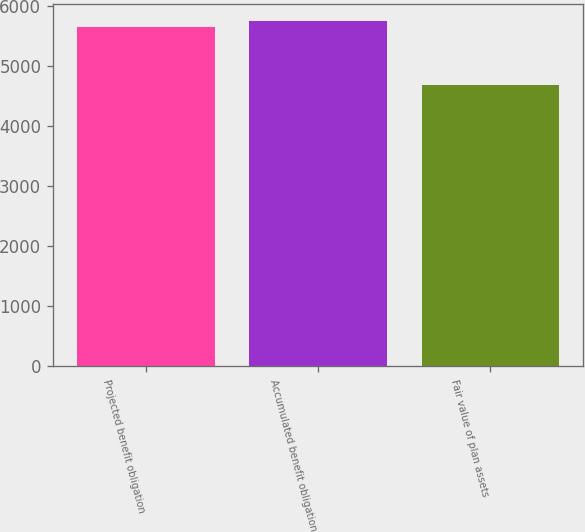Convert chart. <chart><loc_0><loc_0><loc_500><loc_500><bar_chart><fcel>Projected benefit obligation<fcel>Accumulated benefit obligation<fcel>Fair value of plan assets<nl><fcel>5650<fcel>5747.2<fcel>4678<nl></chart> 